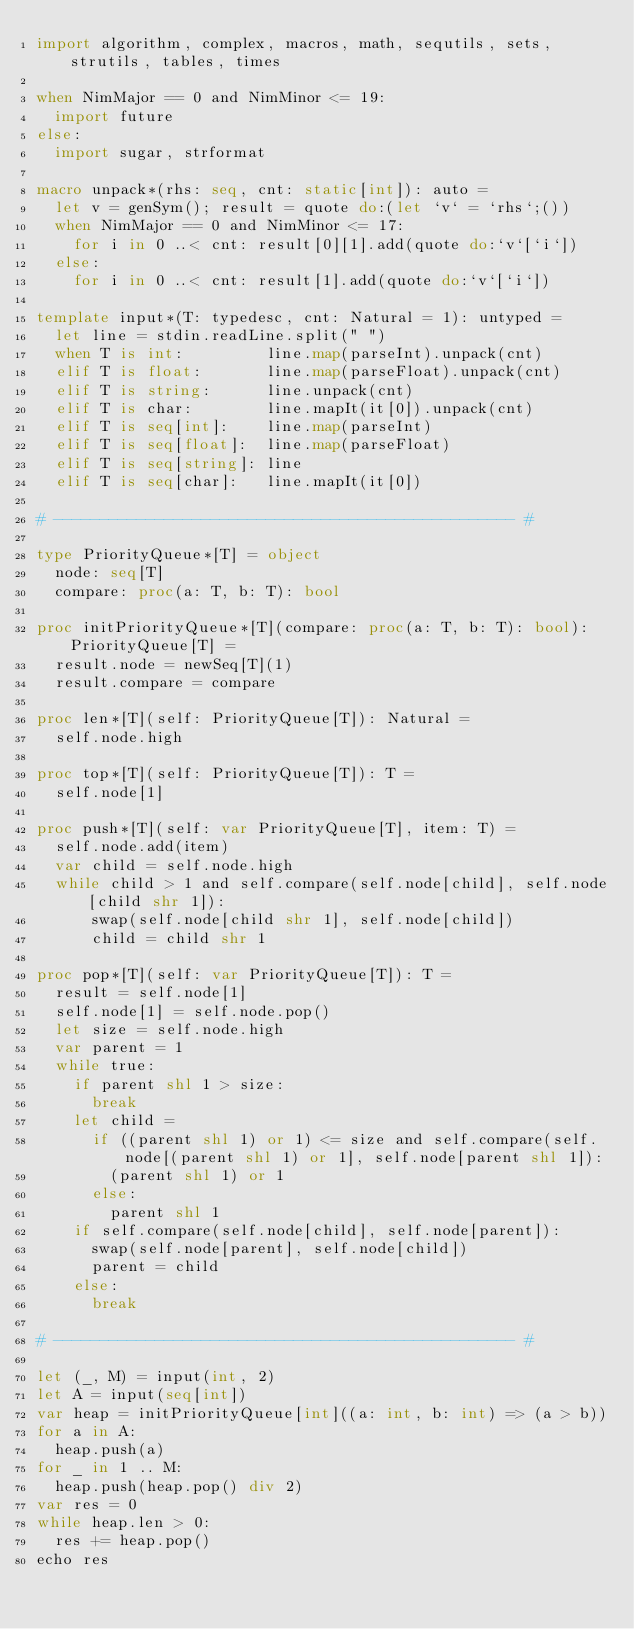<code> <loc_0><loc_0><loc_500><loc_500><_Nim_>import algorithm, complex, macros, math, sequtils, sets, strutils, tables, times

when NimMajor == 0 and NimMinor <= 19:
  import future
else:
  import sugar, strformat

macro unpack*(rhs: seq, cnt: static[int]): auto =
  let v = genSym(); result = quote do:(let `v` = `rhs`;())
  when NimMajor == 0 and NimMinor <= 17:
    for i in 0 ..< cnt: result[0][1].add(quote do:`v`[`i`])
  else:
    for i in 0 ..< cnt: result[1].add(quote do:`v`[`i`])

template input*(T: typedesc, cnt: Natural = 1): untyped =
  let line = stdin.readLine.split(" ")
  when T is int:         line.map(parseInt).unpack(cnt)
  elif T is float:       line.map(parseFloat).unpack(cnt)
  elif T is string:      line.unpack(cnt)
  elif T is char:        line.mapIt(it[0]).unpack(cnt)
  elif T is seq[int]:    line.map(parseInt)
  elif T is seq[float]:  line.map(parseFloat)
  elif T is seq[string]: line
  elif T is seq[char]:   line.mapIt(it[0])

# -------------------------------------------------- #

type PriorityQueue*[T] = object
  node: seq[T]
  compare: proc(a: T, b: T): bool

proc initPriorityQueue*[T](compare: proc(a: T, b: T): bool): PriorityQueue[T] =
  result.node = newSeq[T](1)
  result.compare = compare

proc len*[T](self: PriorityQueue[T]): Natural =
  self.node.high

proc top*[T](self: PriorityQueue[T]): T =
  self.node[1]

proc push*[T](self: var PriorityQueue[T], item: T) =
  self.node.add(item)
  var child = self.node.high
  while child > 1 and self.compare(self.node[child], self.node[child shr 1]):
      swap(self.node[child shr 1], self.node[child])
      child = child shr 1

proc pop*[T](self: var PriorityQueue[T]): T =
  result = self.node[1]
  self.node[1] = self.node.pop()
  let size = self.node.high
  var parent = 1
  while true:
    if parent shl 1 > size:
      break
    let child =
      if ((parent shl 1) or 1) <= size and self.compare(self.node[(parent shl 1) or 1], self.node[parent shl 1]):
        (parent shl 1) or 1
      else:
        parent shl 1
    if self.compare(self.node[child], self.node[parent]):
      swap(self.node[parent], self.node[child])
      parent = child
    else:
      break

# -------------------------------------------------- #

let (_, M) = input(int, 2)
let A = input(seq[int])
var heap = initPriorityQueue[int]((a: int, b: int) => (a > b))
for a in A:
  heap.push(a)
for _ in 1 .. M:
  heap.push(heap.pop() div 2)
var res = 0
while heap.len > 0:
  res += heap.pop()
echo res</code> 